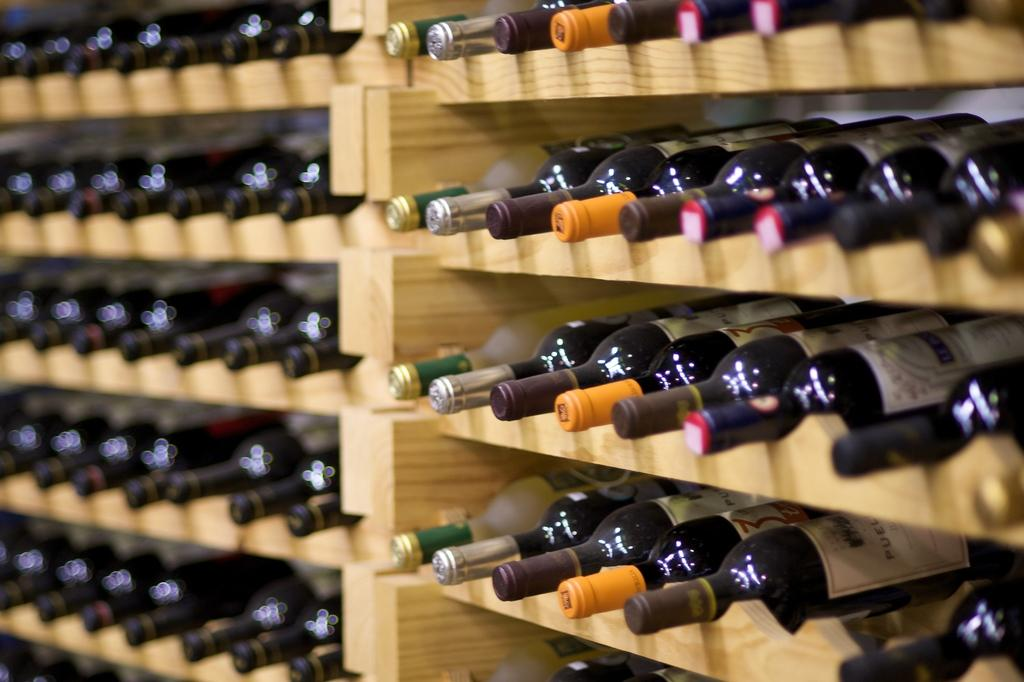What type of containers are visible in the image? There are glass bottles in the image. What can be seen on the glass bottles? The glass bottles have labels on them. How are the glass bottles arranged in the image? The glass bottles are arranged in an order. What type of material is used for the shelves in the image? The wooden shelves are present in the image. Can you tell me how many writers are sitting on the shelf in the image? There are no writers present in the image; it features glass bottles on wooden shelves. Is there any indication that the glass bottles can swim in the image? There is no indication that the glass bottles can swim in the image; they are stationary on the wooden shelves. 